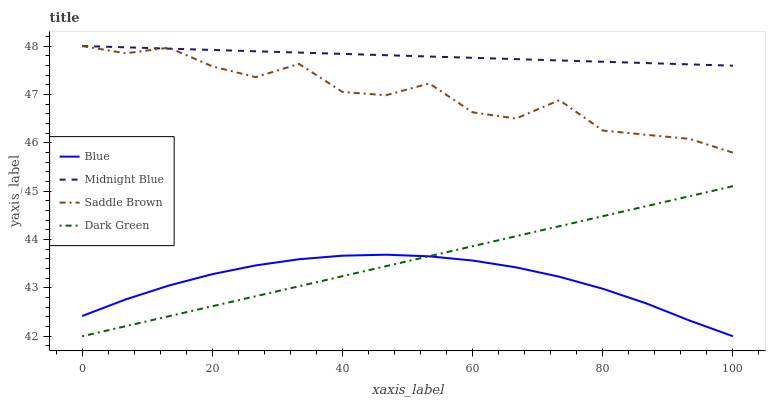Does Blue have the minimum area under the curve?
Answer yes or no. Yes. Does Midnight Blue have the maximum area under the curve?
Answer yes or no. Yes. Does Dark Green have the minimum area under the curve?
Answer yes or no. No. Does Dark Green have the maximum area under the curve?
Answer yes or no. No. Is Midnight Blue the smoothest?
Answer yes or no. Yes. Is Saddle Brown the roughest?
Answer yes or no. Yes. Is Dark Green the smoothest?
Answer yes or no. No. Is Dark Green the roughest?
Answer yes or no. No. Does Blue have the lowest value?
Answer yes or no. Yes. Does Midnight Blue have the lowest value?
Answer yes or no. No. Does Saddle Brown have the highest value?
Answer yes or no. Yes. Does Dark Green have the highest value?
Answer yes or no. No. Is Blue less than Saddle Brown?
Answer yes or no. Yes. Is Saddle Brown greater than Dark Green?
Answer yes or no. Yes. Does Midnight Blue intersect Saddle Brown?
Answer yes or no. Yes. Is Midnight Blue less than Saddle Brown?
Answer yes or no. No. Is Midnight Blue greater than Saddle Brown?
Answer yes or no. No. Does Blue intersect Saddle Brown?
Answer yes or no. No. 